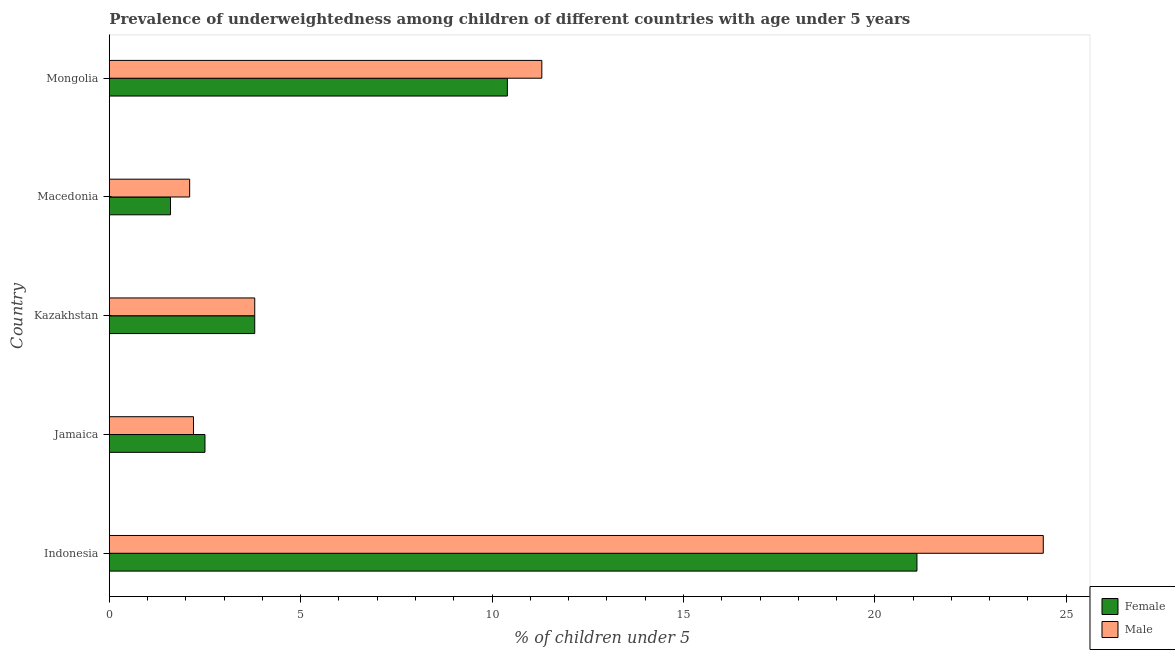How many different coloured bars are there?
Your answer should be compact. 2. Are the number of bars per tick equal to the number of legend labels?
Ensure brevity in your answer.  Yes. How many bars are there on the 5th tick from the top?
Your answer should be very brief. 2. What is the label of the 2nd group of bars from the top?
Ensure brevity in your answer.  Macedonia. In how many cases, is the number of bars for a given country not equal to the number of legend labels?
Your answer should be very brief. 0. What is the percentage of underweighted female children in Indonesia?
Give a very brief answer. 21.1. Across all countries, what is the maximum percentage of underweighted male children?
Ensure brevity in your answer.  24.4. Across all countries, what is the minimum percentage of underweighted female children?
Your answer should be compact. 1.6. In which country was the percentage of underweighted female children minimum?
Your answer should be compact. Macedonia. What is the total percentage of underweighted male children in the graph?
Offer a terse response. 43.8. What is the difference between the percentage of underweighted male children in Jamaica and that in Macedonia?
Your response must be concise. 0.1. What is the difference between the percentage of underweighted female children in Kazakhstan and the percentage of underweighted male children in Jamaica?
Provide a succinct answer. 1.6. What is the average percentage of underweighted female children per country?
Make the answer very short. 7.88. What is the ratio of the percentage of underweighted female children in Indonesia to that in Macedonia?
Ensure brevity in your answer.  13.19. Is the percentage of underweighted male children in Jamaica less than that in Mongolia?
Keep it short and to the point. Yes. Is the difference between the percentage of underweighted male children in Macedonia and Mongolia greater than the difference between the percentage of underweighted female children in Macedonia and Mongolia?
Provide a short and direct response. No. What is the difference between the highest and the second highest percentage of underweighted female children?
Provide a succinct answer. 10.7. What is the difference between the highest and the lowest percentage of underweighted male children?
Ensure brevity in your answer.  22.3. Is the sum of the percentage of underweighted male children in Indonesia and Macedonia greater than the maximum percentage of underweighted female children across all countries?
Offer a terse response. Yes. What does the 2nd bar from the top in Macedonia represents?
Ensure brevity in your answer.  Female. What does the 2nd bar from the bottom in Indonesia represents?
Your response must be concise. Male. How many bars are there?
Keep it short and to the point. 10. Are all the bars in the graph horizontal?
Offer a terse response. Yes. Are the values on the major ticks of X-axis written in scientific E-notation?
Your response must be concise. No. Does the graph contain grids?
Ensure brevity in your answer.  No. Where does the legend appear in the graph?
Make the answer very short. Bottom right. What is the title of the graph?
Your response must be concise. Prevalence of underweightedness among children of different countries with age under 5 years. Does "Urban" appear as one of the legend labels in the graph?
Offer a very short reply. No. What is the label or title of the X-axis?
Your answer should be compact.  % of children under 5. What is the  % of children under 5 of Female in Indonesia?
Offer a terse response. 21.1. What is the  % of children under 5 in Male in Indonesia?
Keep it short and to the point. 24.4. What is the  % of children under 5 in Male in Jamaica?
Make the answer very short. 2.2. What is the  % of children under 5 in Female in Kazakhstan?
Provide a short and direct response. 3.8. What is the  % of children under 5 in Male in Kazakhstan?
Provide a short and direct response. 3.8. What is the  % of children under 5 in Female in Macedonia?
Provide a succinct answer. 1.6. What is the  % of children under 5 of Male in Macedonia?
Provide a short and direct response. 2.1. What is the  % of children under 5 in Female in Mongolia?
Keep it short and to the point. 10.4. What is the  % of children under 5 of Male in Mongolia?
Offer a terse response. 11.3. Across all countries, what is the maximum  % of children under 5 in Female?
Keep it short and to the point. 21.1. Across all countries, what is the maximum  % of children under 5 of Male?
Your answer should be very brief. 24.4. Across all countries, what is the minimum  % of children under 5 in Female?
Your answer should be compact. 1.6. Across all countries, what is the minimum  % of children under 5 in Male?
Ensure brevity in your answer.  2.1. What is the total  % of children under 5 in Female in the graph?
Make the answer very short. 39.4. What is the total  % of children under 5 of Male in the graph?
Make the answer very short. 43.8. What is the difference between the  % of children under 5 of Male in Indonesia and that in Jamaica?
Your answer should be very brief. 22.2. What is the difference between the  % of children under 5 in Male in Indonesia and that in Kazakhstan?
Keep it short and to the point. 20.6. What is the difference between the  % of children under 5 in Female in Indonesia and that in Macedonia?
Offer a very short reply. 19.5. What is the difference between the  % of children under 5 of Male in Indonesia and that in Macedonia?
Your answer should be very brief. 22.3. What is the difference between the  % of children under 5 of Female in Indonesia and that in Mongolia?
Keep it short and to the point. 10.7. What is the difference between the  % of children under 5 in Male in Indonesia and that in Mongolia?
Provide a short and direct response. 13.1. What is the difference between the  % of children under 5 of Female in Jamaica and that in Kazakhstan?
Offer a terse response. -1.3. What is the difference between the  % of children under 5 of Male in Jamaica and that in Kazakhstan?
Your response must be concise. -1.6. What is the difference between the  % of children under 5 of Female in Jamaica and that in Macedonia?
Your response must be concise. 0.9. What is the difference between the  % of children under 5 in Female in Jamaica and that in Mongolia?
Provide a succinct answer. -7.9. What is the difference between the  % of children under 5 in Male in Jamaica and that in Mongolia?
Ensure brevity in your answer.  -9.1. What is the difference between the  % of children under 5 of Female in Kazakhstan and that in Mongolia?
Offer a terse response. -6.6. What is the difference between the  % of children under 5 of Male in Kazakhstan and that in Mongolia?
Provide a succinct answer. -7.5. What is the difference between the  % of children under 5 of Female in Macedonia and that in Mongolia?
Offer a terse response. -8.8. What is the difference between the  % of children under 5 in Male in Macedonia and that in Mongolia?
Provide a short and direct response. -9.2. What is the difference between the  % of children under 5 of Female in Indonesia and the  % of children under 5 of Male in Kazakhstan?
Provide a succinct answer. 17.3. What is the difference between the  % of children under 5 in Female in Indonesia and the  % of children under 5 in Male in Macedonia?
Make the answer very short. 19. What is the difference between the  % of children under 5 in Female in Indonesia and the  % of children under 5 in Male in Mongolia?
Your answer should be very brief. 9.8. What is the difference between the  % of children under 5 in Female in Kazakhstan and the  % of children under 5 in Male in Macedonia?
Offer a terse response. 1.7. What is the difference between the  % of children under 5 of Female in Macedonia and the  % of children under 5 of Male in Mongolia?
Provide a succinct answer. -9.7. What is the average  % of children under 5 in Female per country?
Provide a succinct answer. 7.88. What is the average  % of children under 5 in Male per country?
Give a very brief answer. 8.76. What is the difference between the  % of children under 5 of Female and  % of children under 5 of Male in Indonesia?
Ensure brevity in your answer.  -3.3. What is the difference between the  % of children under 5 in Female and  % of children under 5 in Male in Macedonia?
Make the answer very short. -0.5. What is the ratio of the  % of children under 5 in Female in Indonesia to that in Jamaica?
Offer a very short reply. 8.44. What is the ratio of the  % of children under 5 in Male in Indonesia to that in Jamaica?
Keep it short and to the point. 11.09. What is the ratio of the  % of children under 5 in Female in Indonesia to that in Kazakhstan?
Your response must be concise. 5.55. What is the ratio of the  % of children under 5 of Male in Indonesia to that in Kazakhstan?
Your response must be concise. 6.42. What is the ratio of the  % of children under 5 in Female in Indonesia to that in Macedonia?
Give a very brief answer. 13.19. What is the ratio of the  % of children under 5 in Male in Indonesia to that in Macedonia?
Your answer should be very brief. 11.62. What is the ratio of the  % of children under 5 of Female in Indonesia to that in Mongolia?
Offer a very short reply. 2.03. What is the ratio of the  % of children under 5 of Male in Indonesia to that in Mongolia?
Provide a short and direct response. 2.16. What is the ratio of the  % of children under 5 in Female in Jamaica to that in Kazakhstan?
Give a very brief answer. 0.66. What is the ratio of the  % of children under 5 in Male in Jamaica to that in Kazakhstan?
Provide a succinct answer. 0.58. What is the ratio of the  % of children under 5 of Female in Jamaica to that in Macedonia?
Your response must be concise. 1.56. What is the ratio of the  % of children under 5 in Male in Jamaica to that in Macedonia?
Provide a succinct answer. 1.05. What is the ratio of the  % of children under 5 of Female in Jamaica to that in Mongolia?
Provide a succinct answer. 0.24. What is the ratio of the  % of children under 5 of Male in Jamaica to that in Mongolia?
Offer a very short reply. 0.19. What is the ratio of the  % of children under 5 of Female in Kazakhstan to that in Macedonia?
Give a very brief answer. 2.38. What is the ratio of the  % of children under 5 of Male in Kazakhstan to that in Macedonia?
Provide a succinct answer. 1.81. What is the ratio of the  % of children under 5 in Female in Kazakhstan to that in Mongolia?
Make the answer very short. 0.37. What is the ratio of the  % of children under 5 of Male in Kazakhstan to that in Mongolia?
Provide a succinct answer. 0.34. What is the ratio of the  % of children under 5 of Female in Macedonia to that in Mongolia?
Offer a terse response. 0.15. What is the ratio of the  % of children under 5 in Male in Macedonia to that in Mongolia?
Give a very brief answer. 0.19. What is the difference between the highest and the lowest  % of children under 5 of Male?
Provide a short and direct response. 22.3. 